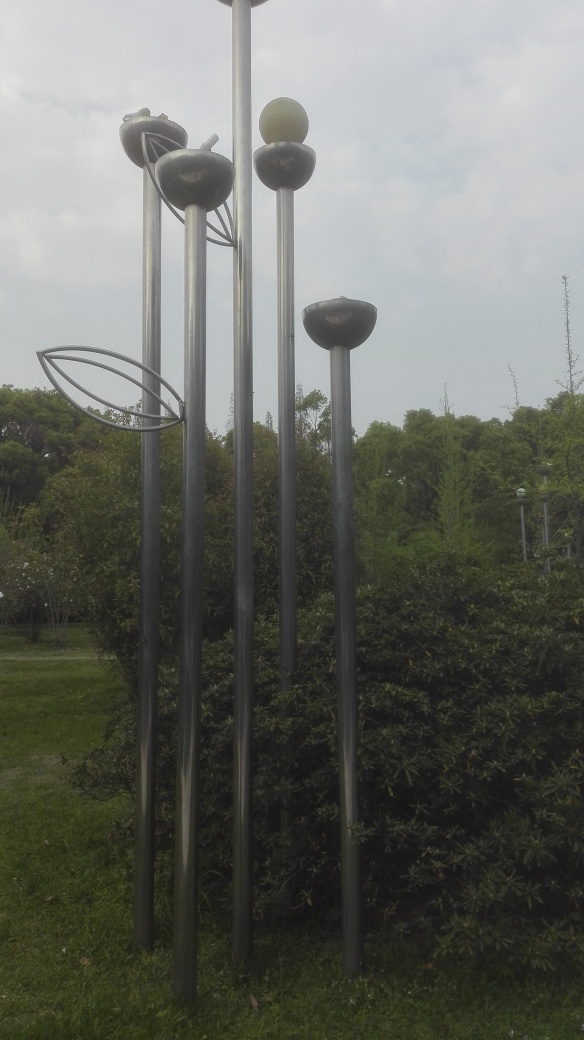What is the artistic concept behind this installation? This installation plays with the concept of scale and surrealism, juxtaposing everyday objects like satellites in an exaggerated size to create a thought-provoking visual experience. Could you tell me more about the elements in the foreground? The foreground features lush greenery, which adds an organic contrast to the metallic and artificial appearance of the sculptures. This combination prompts reflection on the interplay between nature and human-made technology. 